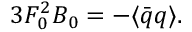Convert formula to latex. <formula><loc_0><loc_0><loc_500><loc_500>3 F _ { 0 } ^ { 2 } B _ { 0 } = - \langle \bar { q } q \rangle .</formula> 